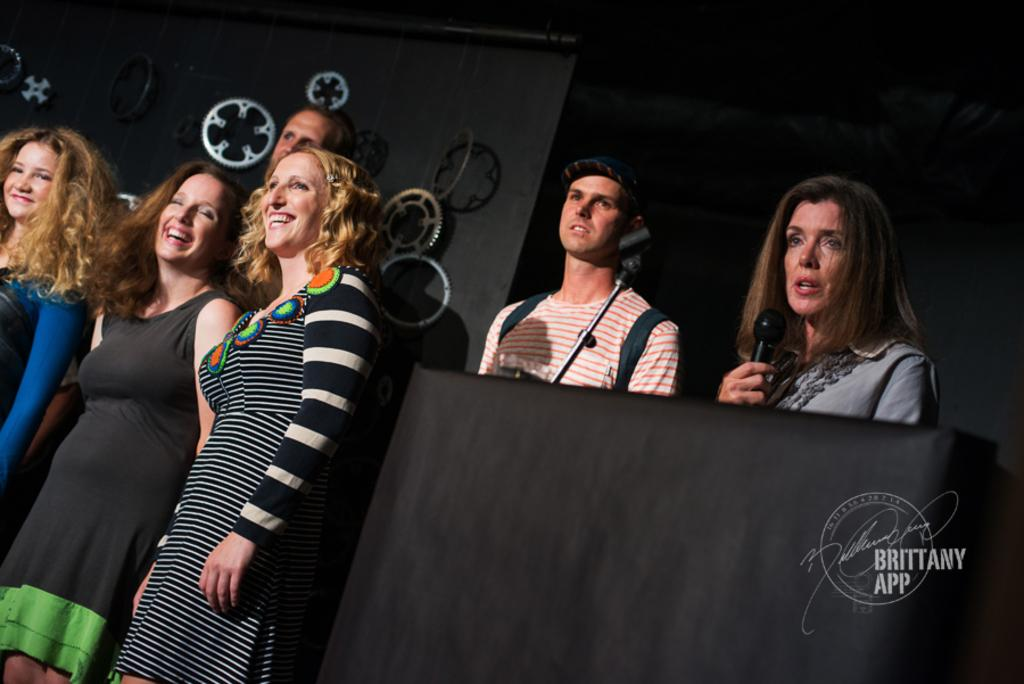What is happening in the image involving a group of people? There is a group of people in the image, and one woman is talking into a microphone. How are the other people in the group reacting to the woman with the microphone? The other people in the group are laughing. What type of trucks can be seen in the image? There are no trucks present in the image. What is the cause of the crack in the microphone in the image? There is no crack in the microphone in the image, and the microphone is not depicted as damaged. 